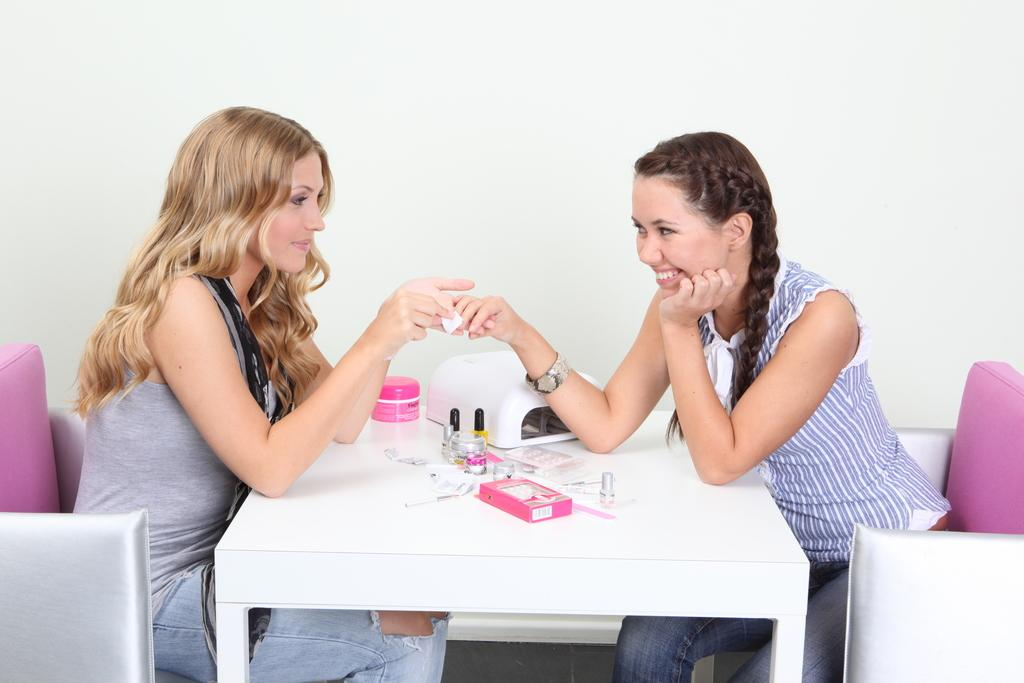What are the people in the image doing? The people in the image are sitting on chairs. Where are the chairs located in relation to each other? The chairs are arranged around a table. What can be found on the table in the image? There are items related to nails on the table. What type of pancake is being served to the people sitting around the table? There is no pancake present in the image; the table contains items related to nails. 